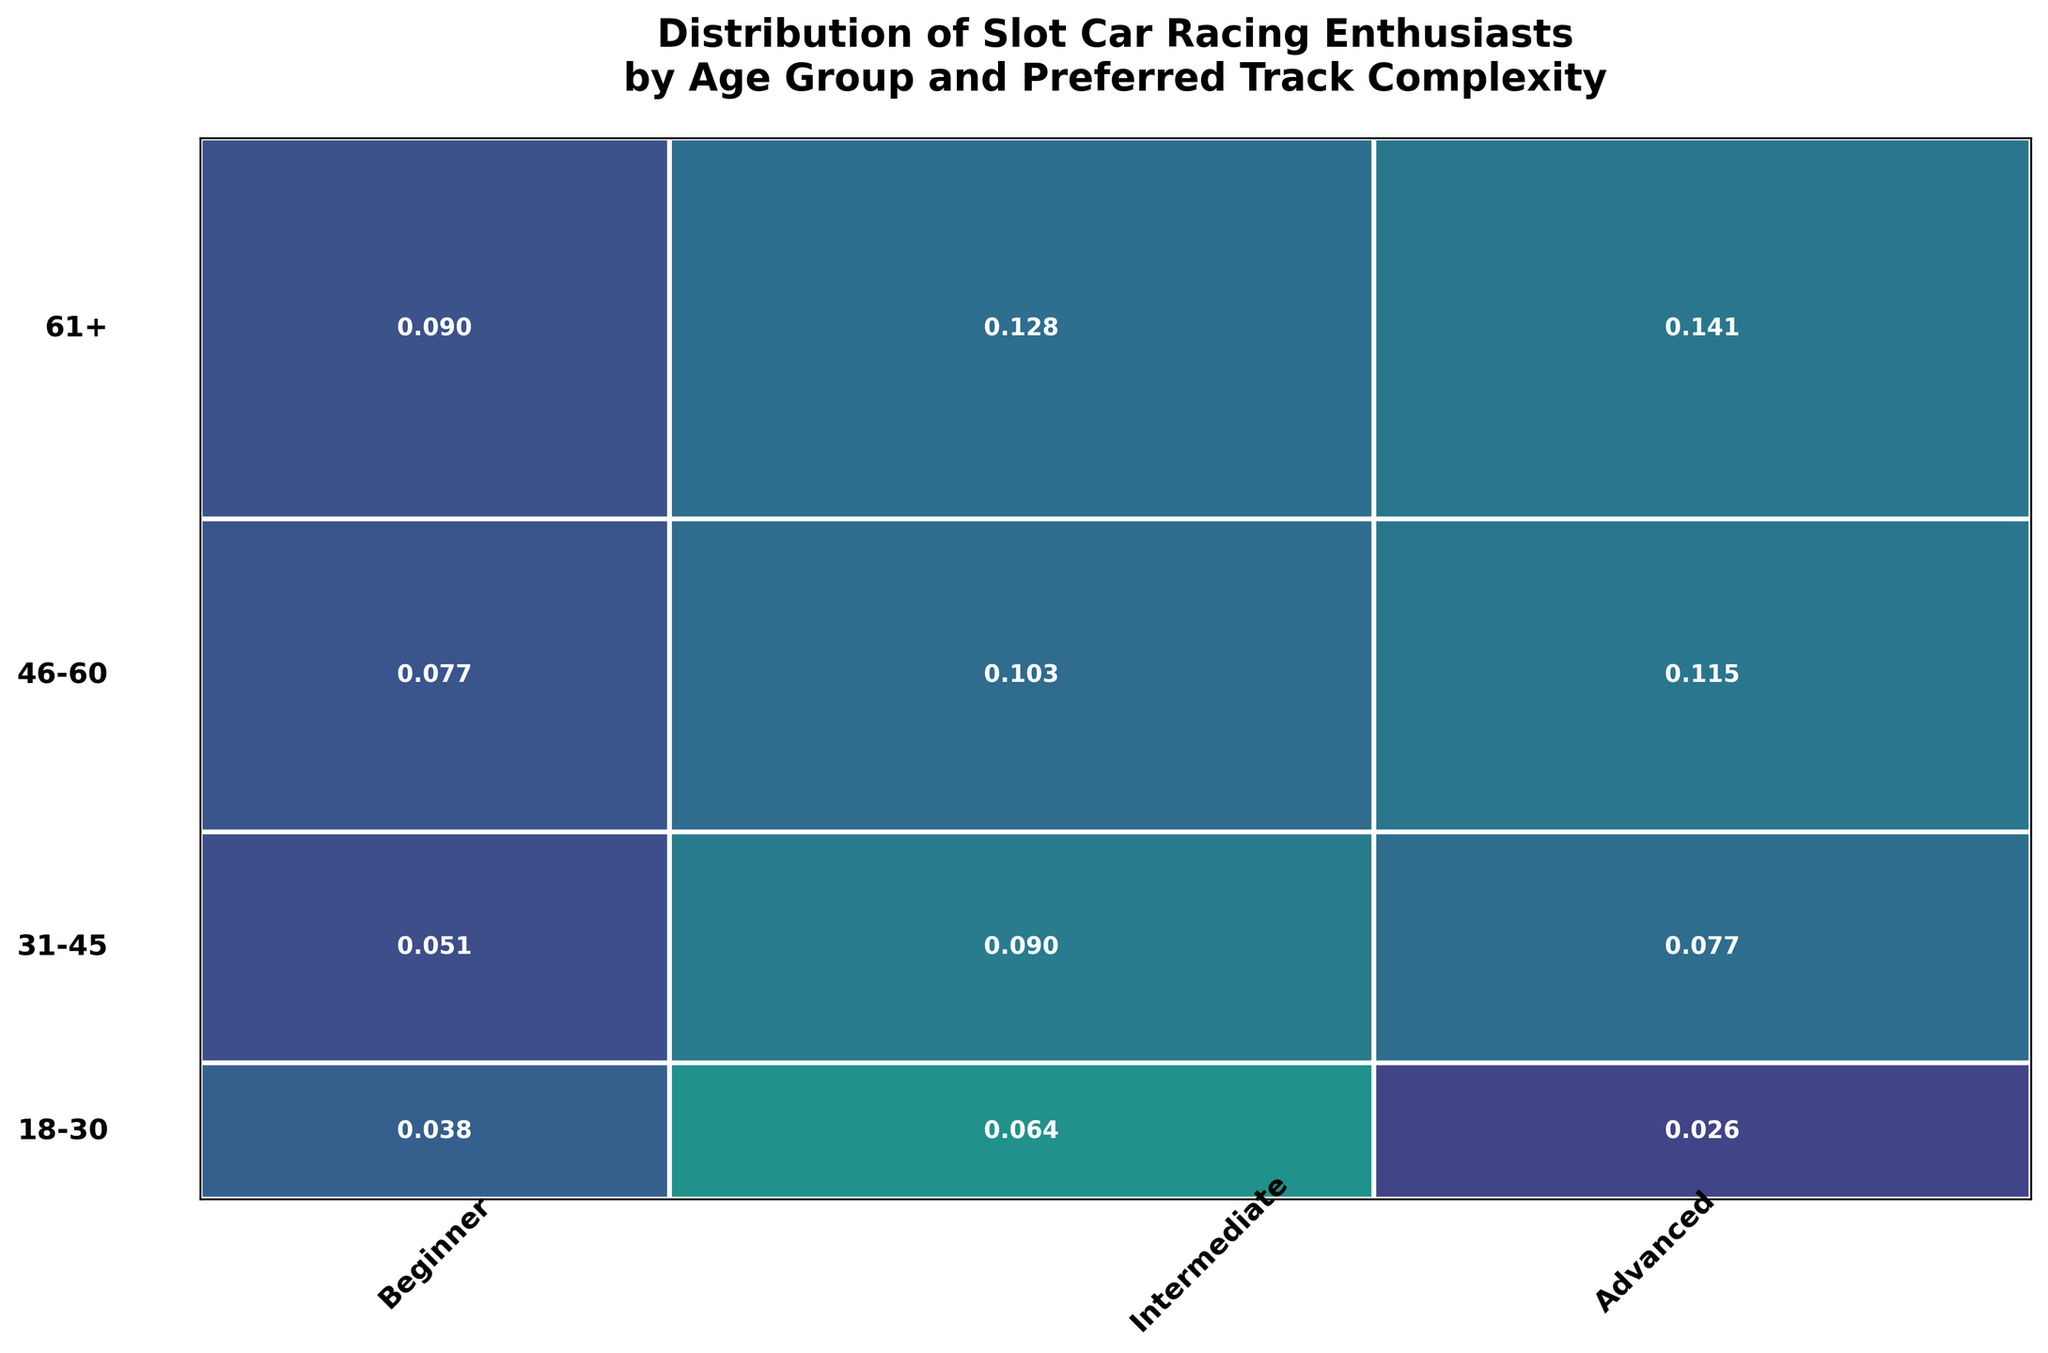What is the title of the figure? The title is typically placed at the top center of the plot. From here, you can read the description directly.
Answer: Distribution of Slot Car Racing Enthusiasts by Age Group and Preferred Track Complexity Which age group has the highest count of enthusiasts for advanced track complexity? Look for the age group with the largest rectangle segment corresponding to 'Advanced' track complexity. This can usually be identified by comparing the sizes visually.
Answer: 61+ Which track complexity is the most popular among the 31-45 age group? Within the 31-45 age group row, identify which track complexity (column) has the largest rectangle segment.
Answer: Intermediate Compare the preference for beginner tracks between the 18-30 and 46-60 age groups. Who prefers them more? Look at the 'Beginner' segments for both the 18-30 and 46-60 age groups, compare the sizes of these segments.
Answer: 46-60 What is the smallest probability value displayed on the mosaics and which age group and track complexity does it correspond to? Identify the smallest numerical value inside the rectangles and check its corresponding row and column.
Answer: 18-30, Advanced What percentage of the total slot car racing enthusiasts are in the 61+ age group? The y-axis size of the '61+' segment represents this group. Check the proportion of this segment in relation to the entire y-axis.
Answer: 0.32 or 32% Which track complexity has the least number of enthusiasts overall? Sum up the widths of the rectangles for each track complexity and find the smallest width.
Answer: Beginner What is the difference in proportions between Intermediate and Advanced preferences in the 46-60 age group? Calculate the difference between the sizes of Intermediate and Advanced segments within the 46-60 age group row. You will subtract one proportion from the other.
Answer: 0.04 (0.18 - 0.14) Which combination of age group and track complexity has the highest probability? Find the largest numerical value inside the rectangles and identify the corresponding age group and track complexity.
Answer: 61+, Advanced 